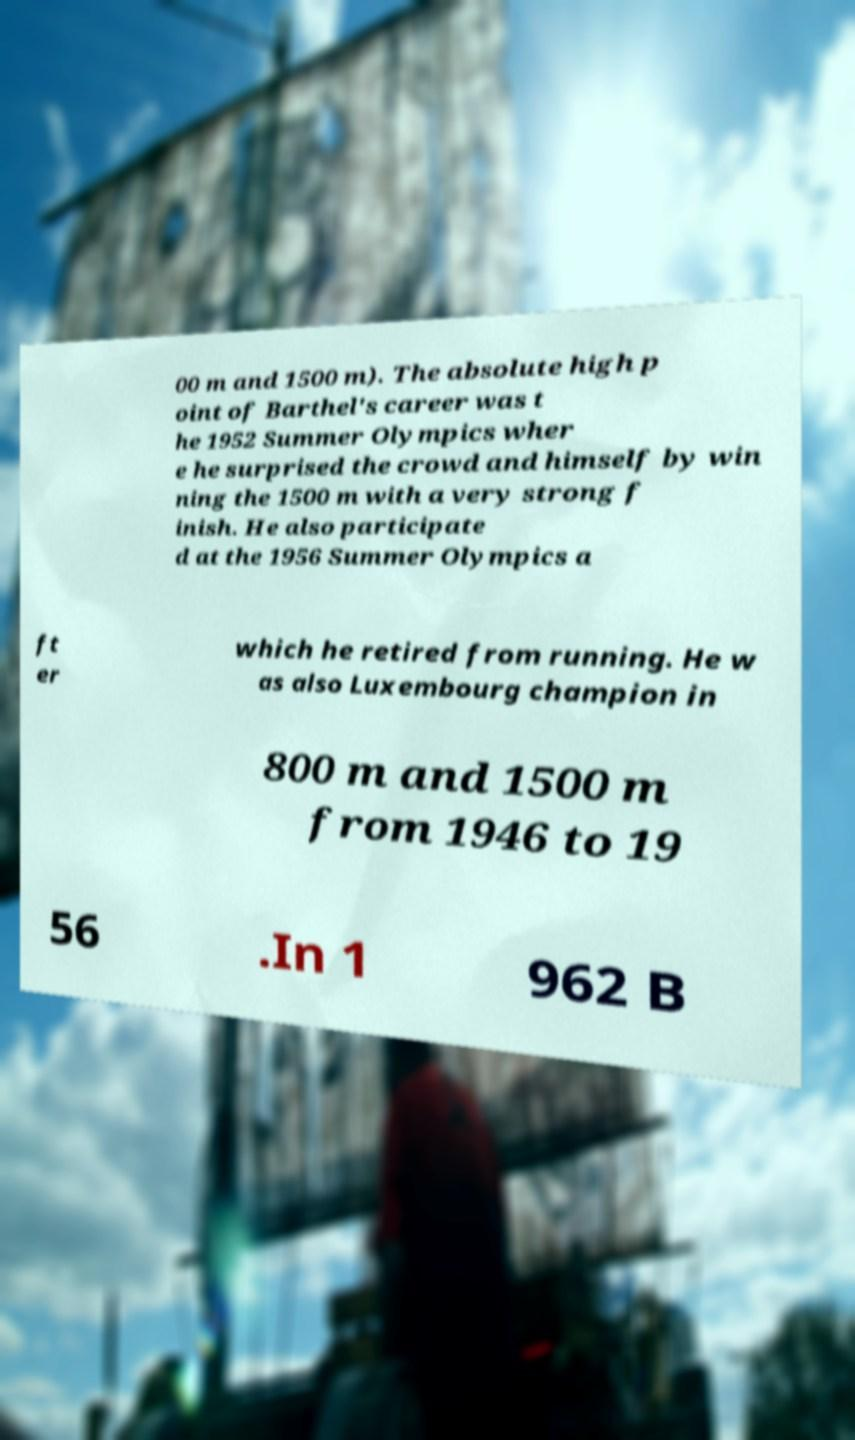Could you assist in decoding the text presented in this image and type it out clearly? 00 m and 1500 m). The absolute high p oint of Barthel's career was t he 1952 Summer Olympics wher e he surprised the crowd and himself by win ning the 1500 m with a very strong f inish. He also participate d at the 1956 Summer Olympics a ft er which he retired from running. He w as also Luxembourg champion in 800 m and 1500 m from 1946 to 19 56 .In 1 962 B 